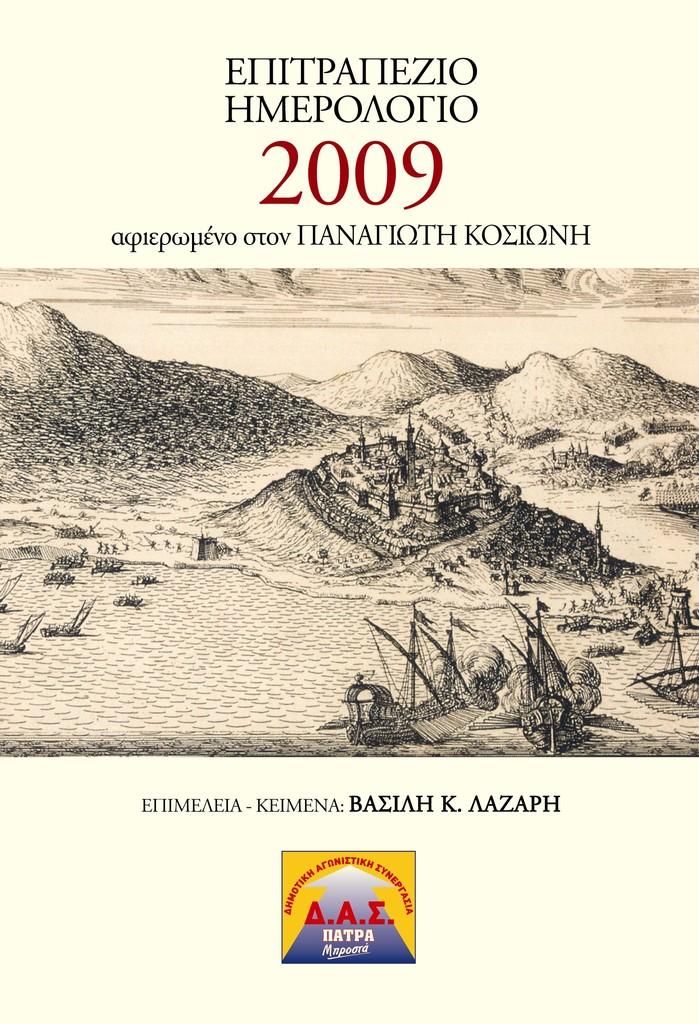What year is shown on the book?
Offer a terse response. 2009. 